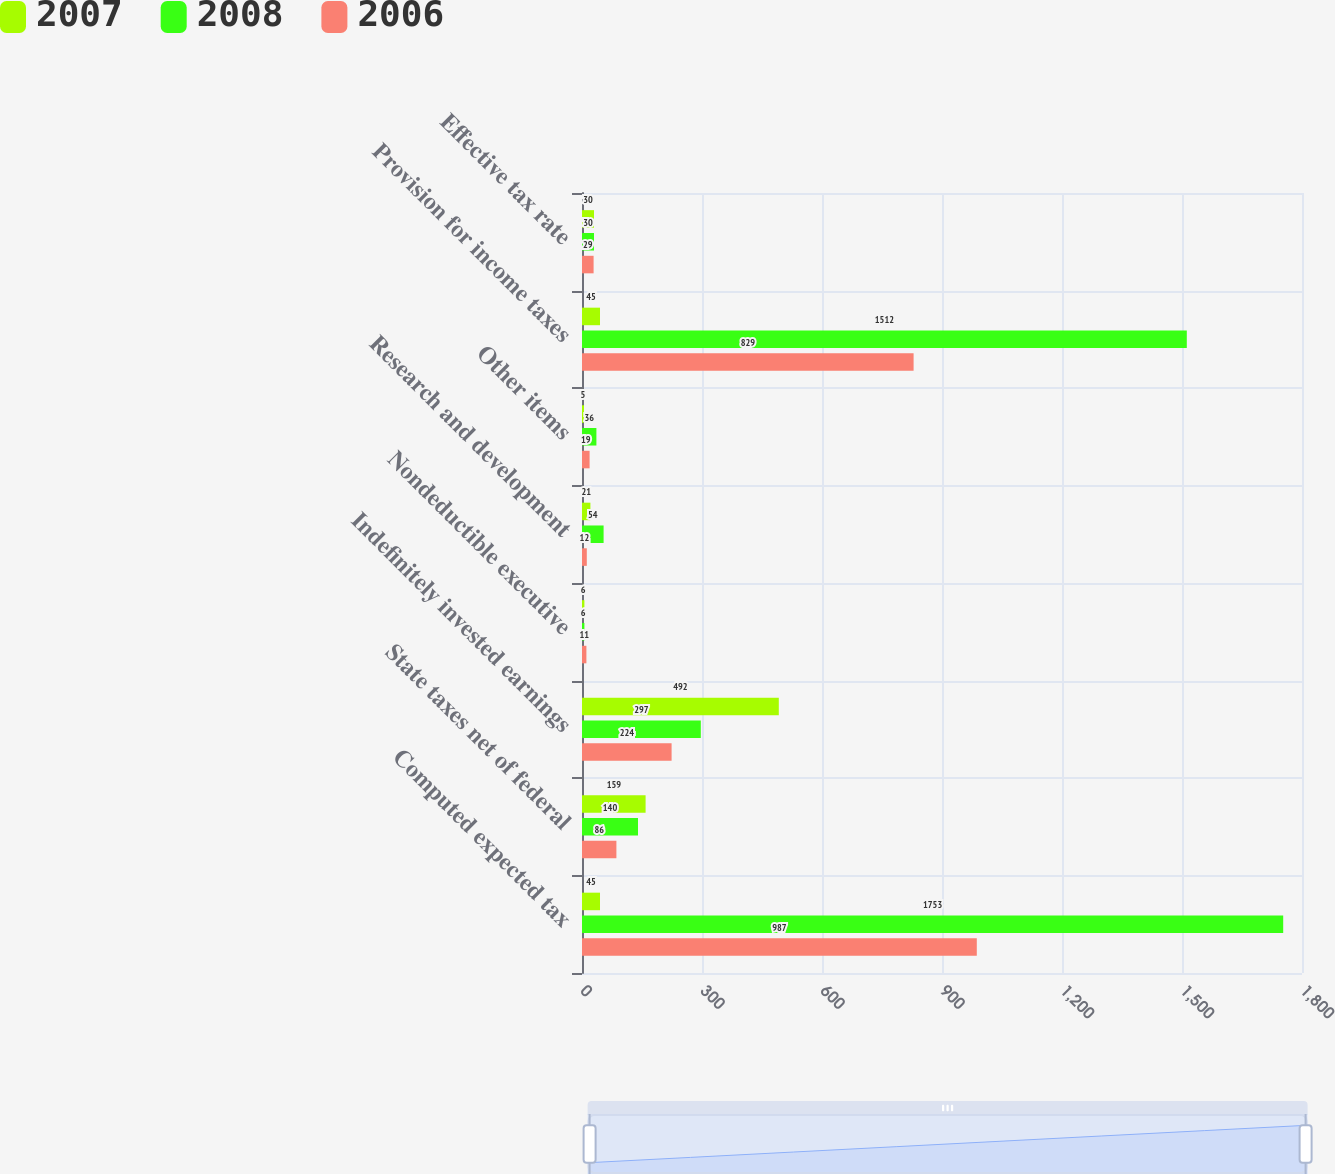Convert chart to OTSL. <chart><loc_0><loc_0><loc_500><loc_500><stacked_bar_chart><ecel><fcel>Computed expected tax<fcel>State taxes net of federal<fcel>Indefinitely invested earnings<fcel>Nondeductible executive<fcel>Research and development<fcel>Other items<fcel>Provision for income taxes<fcel>Effective tax rate<nl><fcel>2007<fcel>45<fcel>159<fcel>492<fcel>6<fcel>21<fcel>5<fcel>45<fcel>30<nl><fcel>2008<fcel>1753<fcel>140<fcel>297<fcel>6<fcel>54<fcel>36<fcel>1512<fcel>30<nl><fcel>2006<fcel>987<fcel>86<fcel>224<fcel>11<fcel>12<fcel>19<fcel>829<fcel>29<nl></chart> 